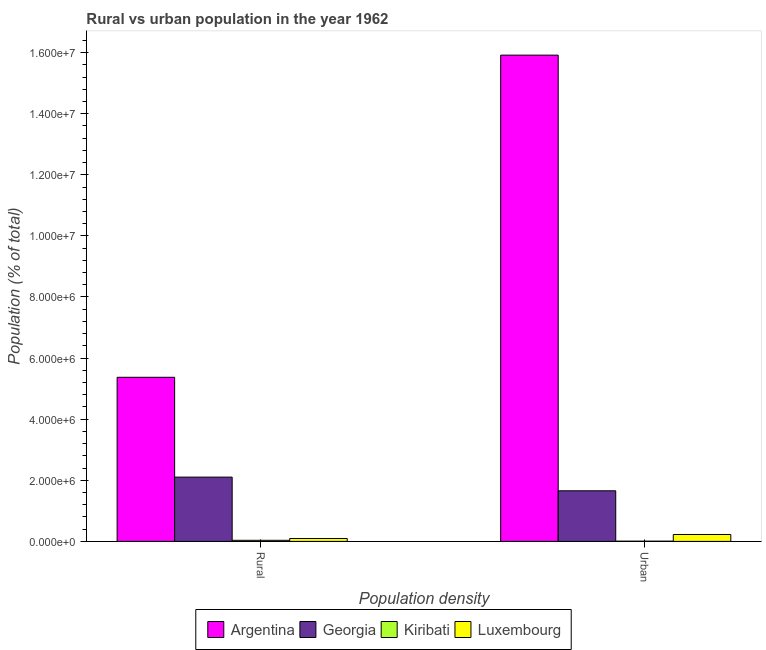Are the number of bars per tick equal to the number of legend labels?
Your answer should be very brief. Yes. How many bars are there on the 1st tick from the left?
Keep it short and to the point. 4. How many bars are there on the 1st tick from the right?
Provide a succinct answer. 4. What is the label of the 1st group of bars from the left?
Make the answer very short. Rural. What is the rural population density in Georgia?
Ensure brevity in your answer.  2.10e+06. Across all countries, what is the maximum urban population density?
Your answer should be compact. 1.59e+07. Across all countries, what is the minimum urban population density?
Give a very brief answer. 7608. In which country was the urban population density minimum?
Your response must be concise. Kiribati. What is the total rural population density in the graph?
Offer a terse response. 7.61e+06. What is the difference between the urban population density in Georgia and that in Kiribati?
Provide a succinct answer. 1.65e+06. What is the difference between the rural population density in Argentina and the urban population density in Luxembourg?
Provide a short and direct response. 5.15e+06. What is the average rural population density per country?
Offer a terse response. 1.90e+06. What is the difference between the urban population density and rural population density in Georgia?
Your response must be concise. -4.47e+05. In how many countries, is the rural population density greater than 4800000 %?
Offer a terse response. 1. What is the ratio of the rural population density in Argentina to that in Kiribati?
Provide a succinct answer. 150.45. Is the urban population density in Kiribati less than that in Georgia?
Offer a terse response. Yes. What does the 2nd bar from the left in Urban represents?
Ensure brevity in your answer.  Georgia. Does the graph contain any zero values?
Offer a terse response. No. Where does the legend appear in the graph?
Keep it short and to the point. Bottom center. What is the title of the graph?
Keep it short and to the point. Rural vs urban population in the year 1962. What is the label or title of the X-axis?
Give a very brief answer. Population density. What is the label or title of the Y-axis?
Ensure brevity in your answer.  Population (% of total). What is the Population (% of total) in Argentina in Rural?
Make the answer very short. 5.37e+06. What is the Population (% of total) of Georgia in Rural?
Your response must be concise. 2.10e+06. What is the Population (% of total) of Kiribati in Rural?
Your answer should be very brief. 3.57e+04. What is the Population (% of total) in Luxembourg in Rural?
Your answer should be compact. 9.48e+04. What is the Population (% of total) of Argentina in Urban?
Your response must be concise. 1.59e+07. What is the Population (% of total) in Georgia in Urban?
Offer a terse response. 1.66e+06. What is the Population (% of total) in Kiribati in Urban?
Provide a short and direct response. 7608. What is the Population (% of total) of Luxembourg in Urban?
Your answer should be compact. 2.26e+05. Across all Population density, what is the maximum Population (% of total) of Argentina?
Provide a short and direct response. 1.59e+07. Across all Population density, what is the maximum Population (% of total) in Georgia?
Your response must be concise. 2.10e+06. Across all Population density, what is the maximum Population (% of total) in Kiribati?
Give a very brief answer. 3.57e+04. Across all Population density, what is the maximum Population (% of total) of Luxembourg?
Provide a succinct answer. 2.26e+05. Across all Population density, what is the minimum Population (% of total) in Argentina?
Your answer should be compact. 5.37e+06. Across all Population density, what is the minimum Population (% of total) of Georgia?
Your response must be concise. 1.66e+06. Across all Population density, what is the minimum Population (% of total) of Kiribati?
Offer a very short reply. 7608. Across all Population density, what is the minimum Population (% of total) in Luxembourg?
Keep it short and to the point. 9.48e+04. What is the total Population (% of total) of Argentina in the graph?
Your answer should be compact. 2.13e+07. What is the total Population (% of total) in Georgia in the graph?
Provide a short and direct response. 3.76e+06. What is the total Population (% of total) of Kiribati in the graph?
Your answer should be compact. 4.33e+04. What is the total Population (% of total) in Luxembourg in the graph?
Provide a succinct answer. 3.21e+05. What is the difference between the Population (% of total) of Argentina in Rural and that in Urban?
Make the answer very short. -1.05e+07. What is the difference between the Population (% of total) of Georgia in Rural and that in Urban?
Offer a terse response. 4.47e+05. What is the difference between the Population (% of total) in Kiribati in Rural and that in Urban?
Ensure brevity in your answer.  2.81e+04. What is the difference between the Population (% of total) in Luxembourg in Rural and that in Urban?
Your response must be concise. -1.31e+05. What is the difference between the Population (% of total) in Argentina in Rural and the Population (% of total) in Georgia in Urban?
Provide a short and direct response. 3.72e+06. What is the difference between the Population (% of total) in Argentina in Rural and the Population (% of total) in Kiribati in Urban?
Provide a short and direct response. 5.36e+06. What is the difference between the Population (% of total) of Argentina in Rural and the Population (% of total) of Luxembourg in Urban?
Offer a terse response. 5.15e+06. What is the difference between the Population (% of total) in Georgia in Rural and the Population (% of total) in Kiribati in Urban?
Offer a very short reply. 2.10e+06. What is the difference between the Population (% of total) in Georgia in Rural and the Population (% of total) in Luxembourg in Urban?
Provide a succinct answer. 1.88e+06. What is the difference between the Population (% of total) of Kiribati in Rural and the Population (% of total) of Luxembourg in Urban?
Make the answer very short. -1.90e+05. What is the average Population (% of total) in Argentina per Population density?
Keep it short and to the point. 1.06e+07. What is the average Population (% of total) of Georgia per Population density?
Give a very brief answer. 1.88e+06. What is the average Population (% of total) of Kiribati per Population density?
Provide a short and direct response. 2.17e+04. What is the average Population (% of total) in Luxembourg per Population density?
Keep it short and to the point. 1.60e+05. What is the difference between the Population (% of total) in Argentina and Population (% of total) in Georgia in Rural?
Make the answer very short. 3.27e+06. What is the difference between the Population (% of total) in Argentina and Population (% of total) in Kiribati in Rural?
Your response must be concise. 5.34e+06. What is the difference between the Population (% of total) in Argentina and Population (% of total) in Luxembourg in Rural?
Offer a very short reply. 5.28e+06. What is the difference between the Population (% of total) of Georgia and Population (% of total) of Kiribati in Rural?
Your answer should be very brief. 2.07e+06. What is the difference between the Population (% of total) in Georgia and Population (% of total) in Luxembourg in Rural?
Your answer should be compact. 2.01e+06. What is the difference between the Population (% of total) of Kiribati and Population (% of total) of Luxembourg in Rural?
Provide a short and direct response. -5.91e+04. What is the difference between the Population (% of total) in Argentina and Population (% of total) in Georgia in Urban?
Give a very brief answer. 1.43e+07. What is the difference between the Population (% of total) of Argentina and Population (% of total) of Kiribati in Urban?
Provide a short and direct response. 1.59e+07. What is the difference between the Population (% of total) in Argentina and Population (% of total) in Luxembourg in Urban?
Your answer should be very brief. 1.57e+07. What is the difference between the Population (% of total) of Georgia and Population (% of total) of Kiribati in Urban?
Provide a succinct answer. 1.65e+06. What is the difference between the Population (% of total) of Georgia and Population (% of total) of Luxembourg in Urban?
Provide a short and direct response. 1.43e+06. What is the difference between the Population (% of total) in Kiribati and Population (% of total) in Luxembourg in Urban?
Your answer should be compact. -2.18e+05. What is the ratio of the Population (% of total) of Argentina in Rural to that in Urban?
Offer a very short reply. 0.34. What is the ratio of the Population (% of total) of Georgia in Rural to that in Urban?
Offer a very short reply. 1.27. What is the ratio of the Population (% of total) of Kiribati in Rural to that in Urban?
Offer a very short reply. 4.69. What is the ratio of the Population (% of total) of Luxembourg in Rural to that in Urban?
Provide a short and direct response. 0.42. What is the difference between the highest and the second highest Population (% of total) in Argentina?
Provide a short and direct response. 1.05e+07. What is the difference between the highest and the second highest Population (% of total) in Georgia?
Keep it short and to the point. 4.47e+05. What is the difference between the highest and the second highest Population (% of total) of Kiribati?
Provide a short and direct response. 2.81e+04. What is the difference between the highest and the second highest Population (% of total) in Luxembourg?
Make the answer very short. 1.31e+05. What is the difference between the highest and the lowest Population (% of total) of Argentina?
Your response must be concise. 1.05e+07. What is the difference between the highest and the lowest Population (% of total) in Georgia?
Give a very brief answer. 4.47e+05. What is the difference between the highest and the lowest Population (% of total) of Kiribati?
Provide a succinct answer. 2.81e+04. What is the difference between the highest and the lowest Population (% of total) in Luxembourg?
Provide a short and direct response. 1.31e+05. 